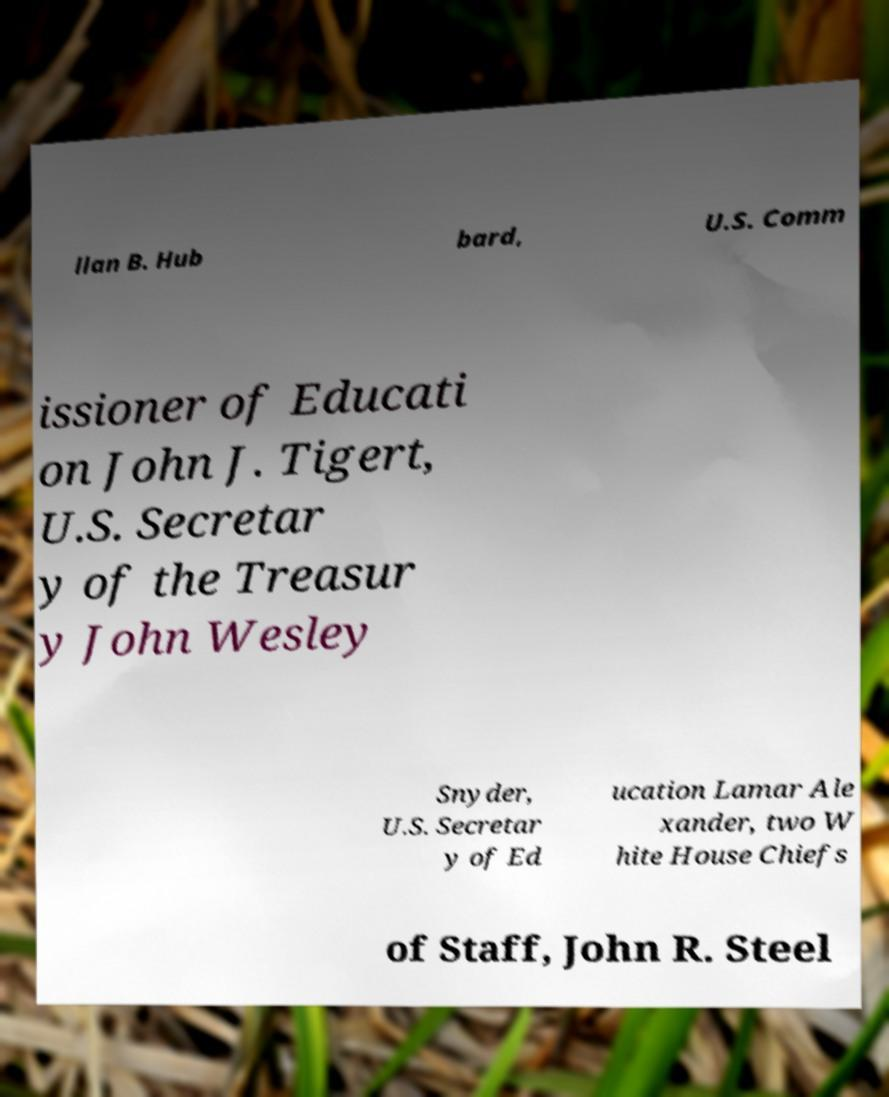I need the written content from this picture converted into text. Can you do that? llan B. Hub bard, U.S. Comm issioner of Educati on John J. Tigert, U.S. Secretar y of the Treasur y John Wesley Snyder, U.S. Secretar y of Ed ucation Lamar Ale xander, two W hite House Chiefs of Staff, John R. Steel 